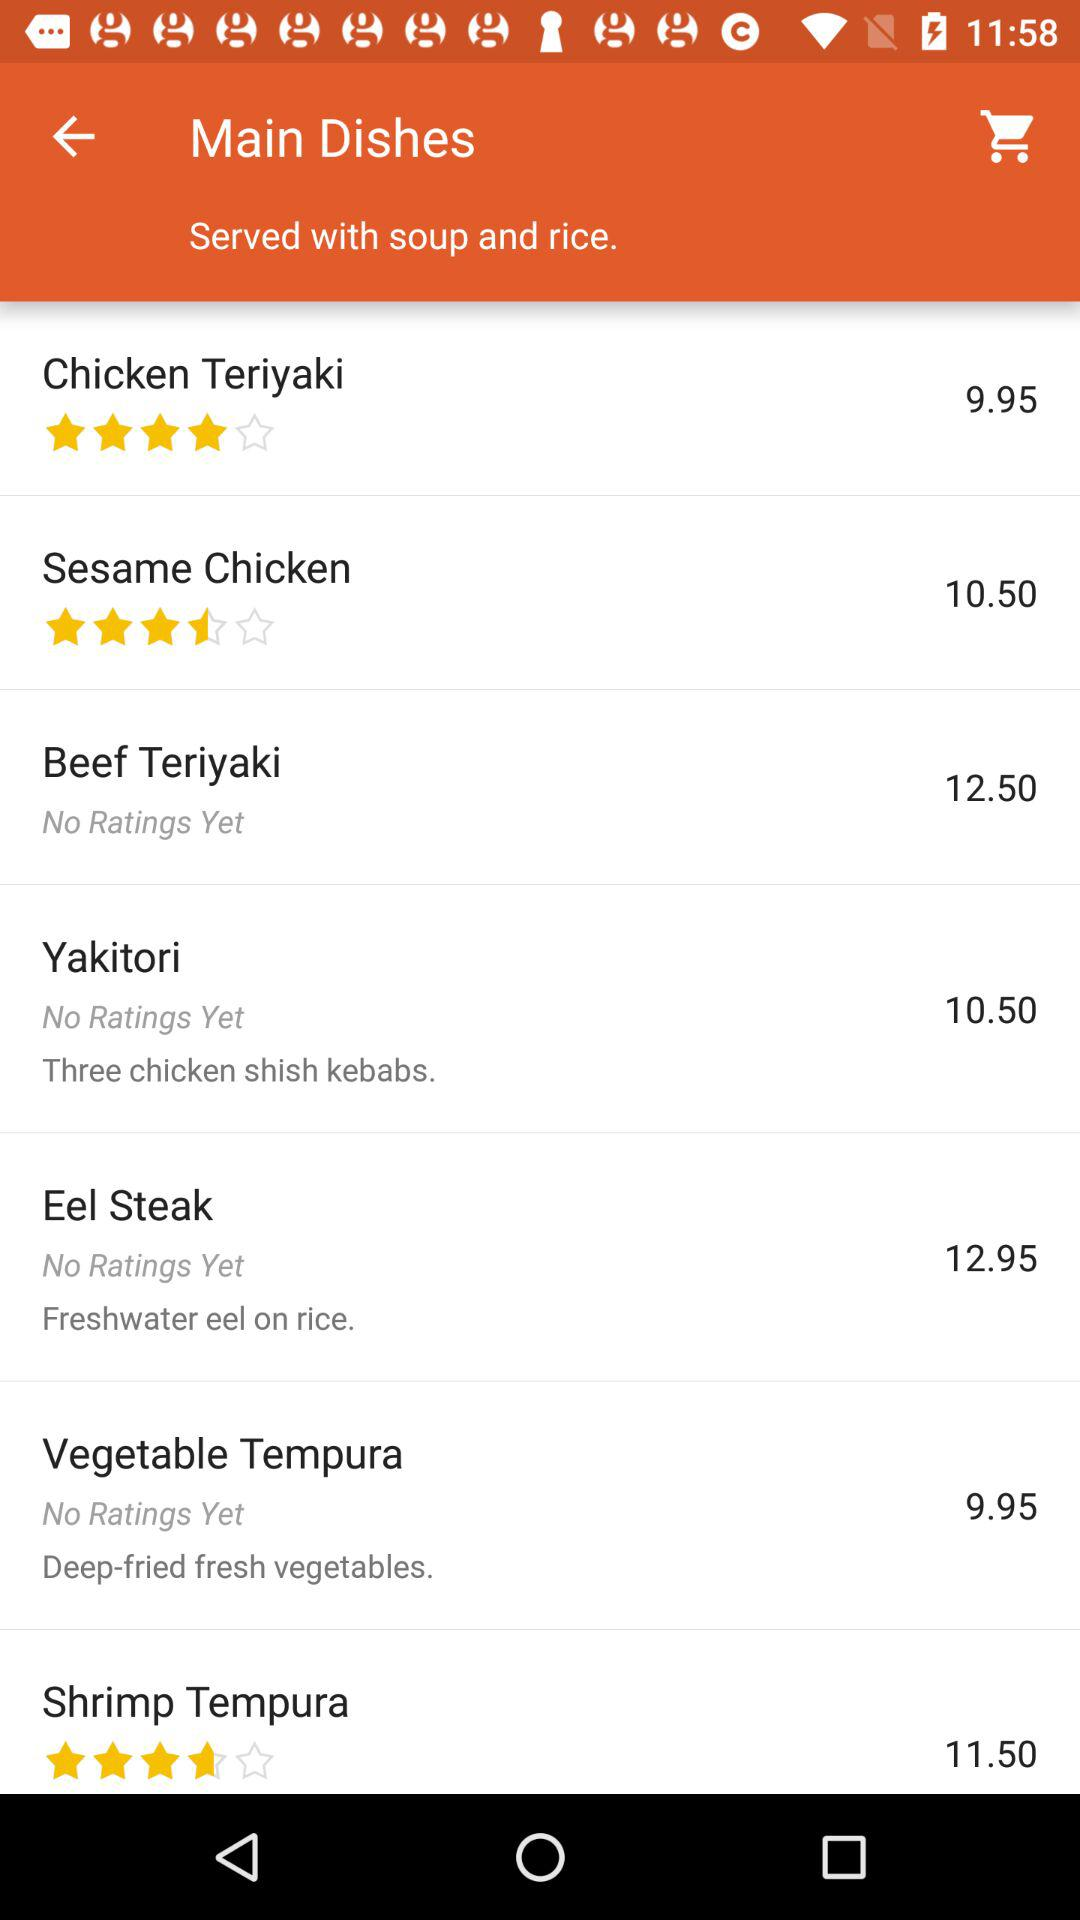What is the rating of "Chicken Teriyaki"? The rating is 4 stars. 